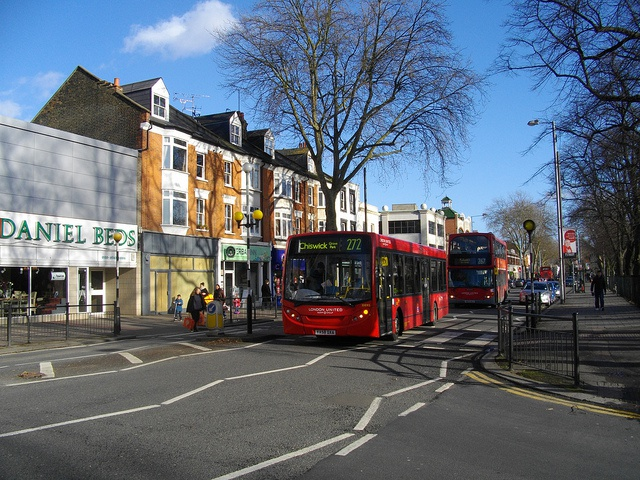Describe the objects in this image and their specific colors. I can see bus in gray, black, maroon, and brown tones, bus in gray, black, maroon, and navy tones, car in gray, black, lightgray, and navy tones, people in gray and black tones, and people in gray, black, and maroon tones in this image. 